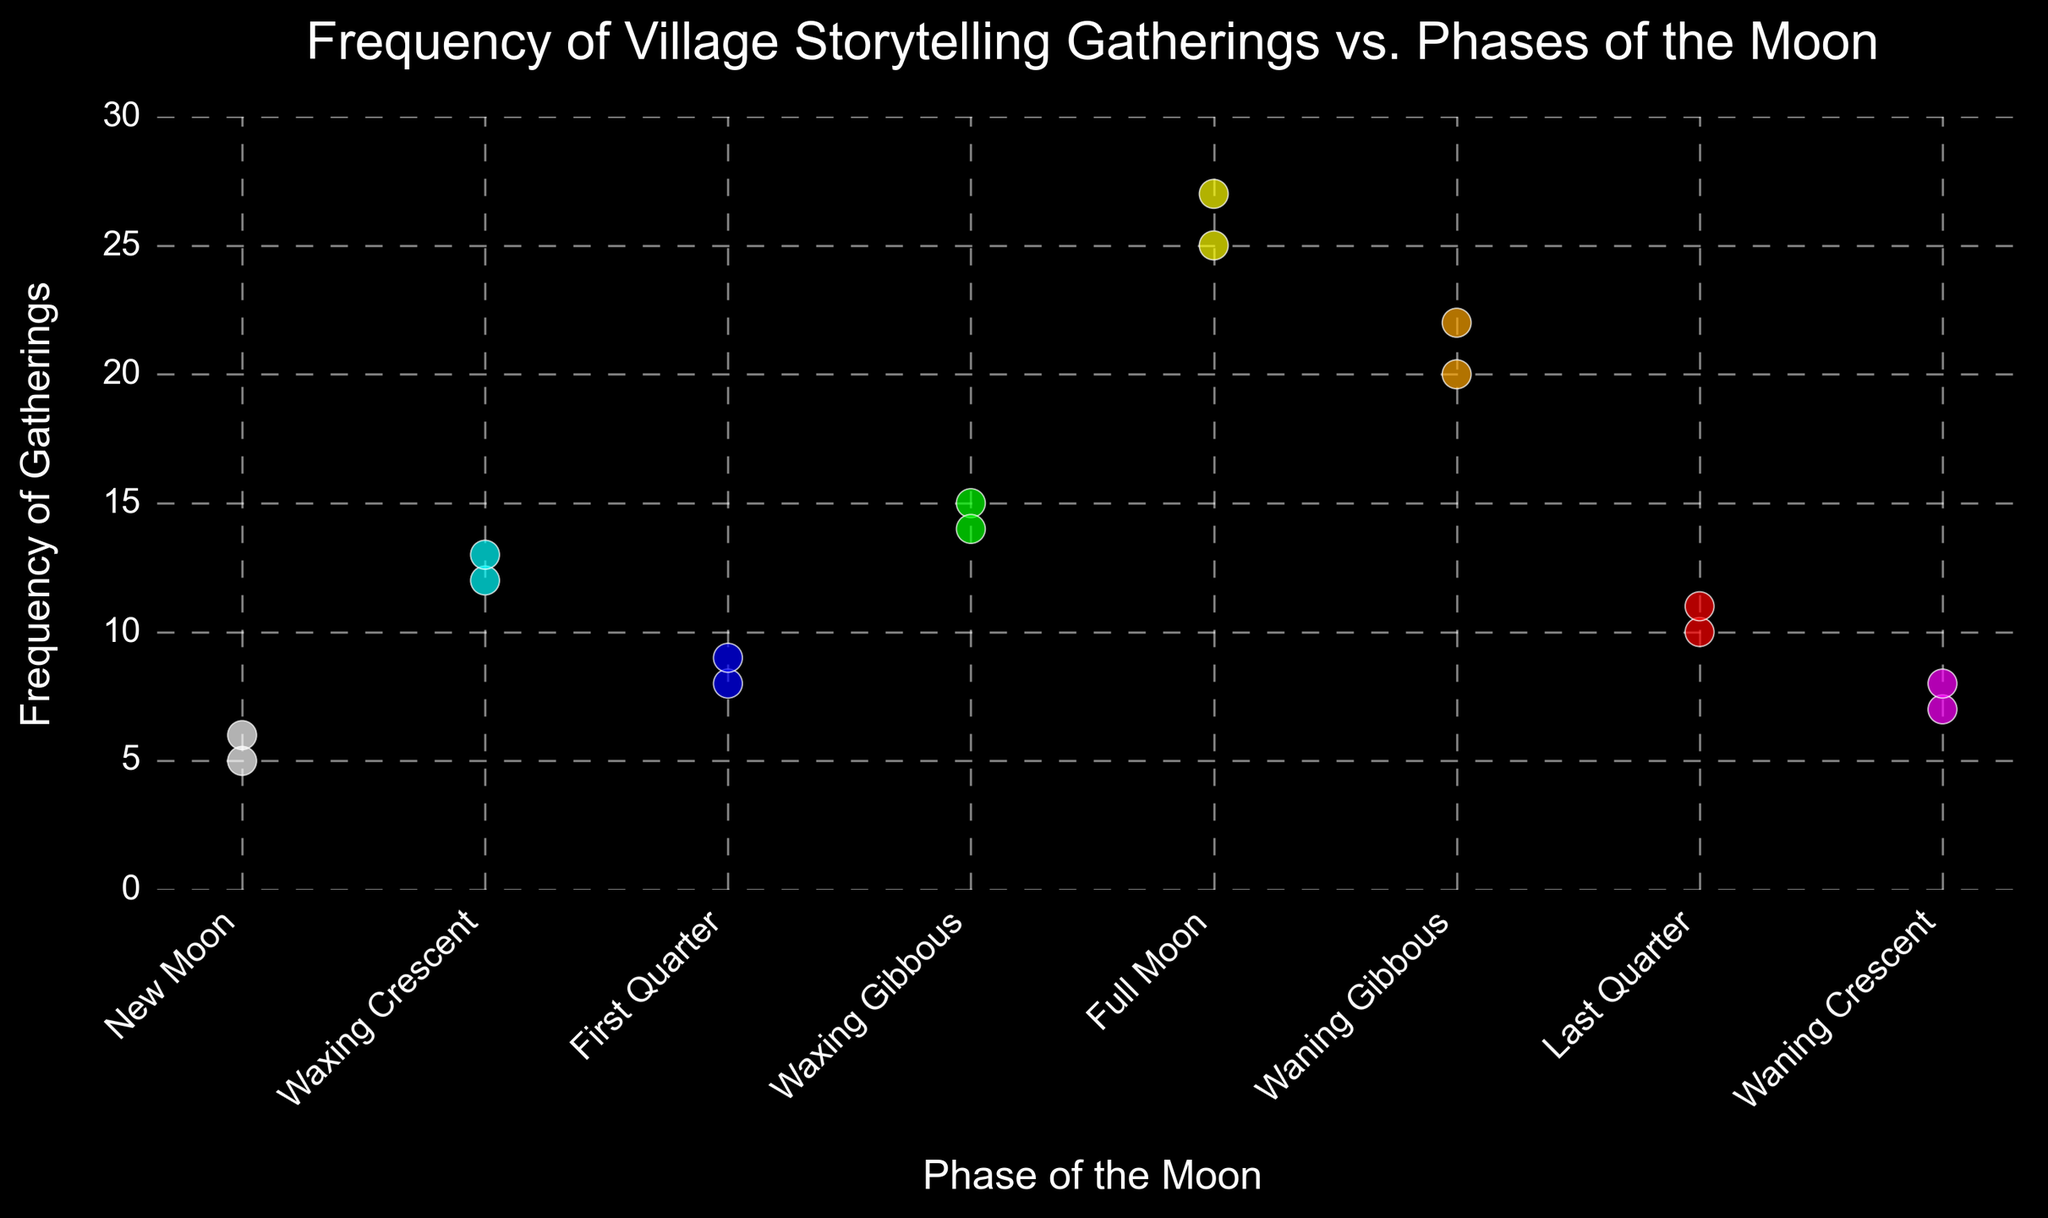Which moon phase has the highest frequency of gatherings? The graph shows that the Full Moon phase has the highest data points.
Answer: Full Moon Among the Full Moon and New Moon phases, which has a lower frequency of gatherings? The data points for the New Moon phase are consistently lower than those for the Full Moon phase.
Answer: New Moon What is the average frequency of gatherings during the Waxing Crescent phase? There are two data points for the Waxing Crescent phase, 12 and 13. The average is (12 + 13) / 2 = 12.5.
Answer: 12.5 Compare the frequency of gatherings during the Waning Gibbous and the Last Quarter phases, which phase has more frequent gatherings? The data points for the Waning Gibbous phase are 20 and 22, while the Last Quarter phase shows 10 and 11. Hence, the Waning Gibbous phase has more frequent gatherings.
Answer: Waning Gibbous What is the range of frequencies observed during the First Quarter phase? The data points for the First Quarter phase are 8 and 9. The range is 9 - 8 = 1.
Answer: 1 Which moon phase has the highest variability in terms of gathering frequency? By visually inspecting the spread of data points, the Full Moon phase, with points at 25 and 27, seems to have the highest variability.
Answer: Full Moon How much more frequent are gatherings during the Full Moon than during the Waxing Gibbous phase on average? The average frequency for the Full Moon is (25+27)/2 = 26, and for the Waxing Gibbous is (15+14)/2 = 14.5. The difference is 26 - 14.5 = 11.5.
Answer: 11.5 Considering the waxing phases (Waxing Crescent, First Quarter, Waxing Gibbous) and the waning phases (Waning Gibbous, Last Quarter, Waning Crescent), which group has higher average gatherings? For waxing phases: (12+13+8+9+15+14)/6 = 11.83. For waning phases: (20+22+10+11+7+8)/6 = 13.
Answer: Waning phases What is the combined total of frequencies for all phases of the moon? Sum all frequencies: (5+12+8+15+25+20+10+7+6+13+9+14+27+22+11+8)=212.
Answer: 212 